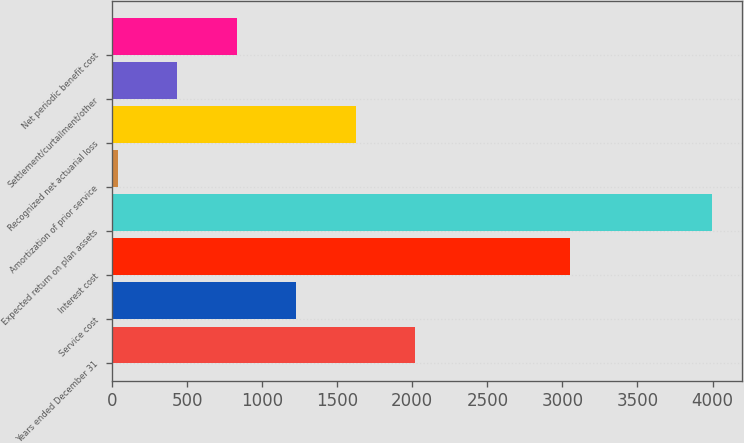Convert chart to OTSL. <chart><loc_0><loc_0><loc_500><loc_500><bar_chart><fcel>Years ended December 31<fcel>Service cost<fcel>Interest cost<fcel>Expected return on plan assets<fcel>Amortization of prior service<fcel>Recognized net actuarial loss<fcel>Settlement/curtailment/other<fcel>Net periodic benefit cost<nl><fcel>2018.5<fcel>1226.3<fcel>3050<fcel>3999<fcel>38<fcel>1622.4<fcel>434.1<fcel>830.2<nl></chart> 